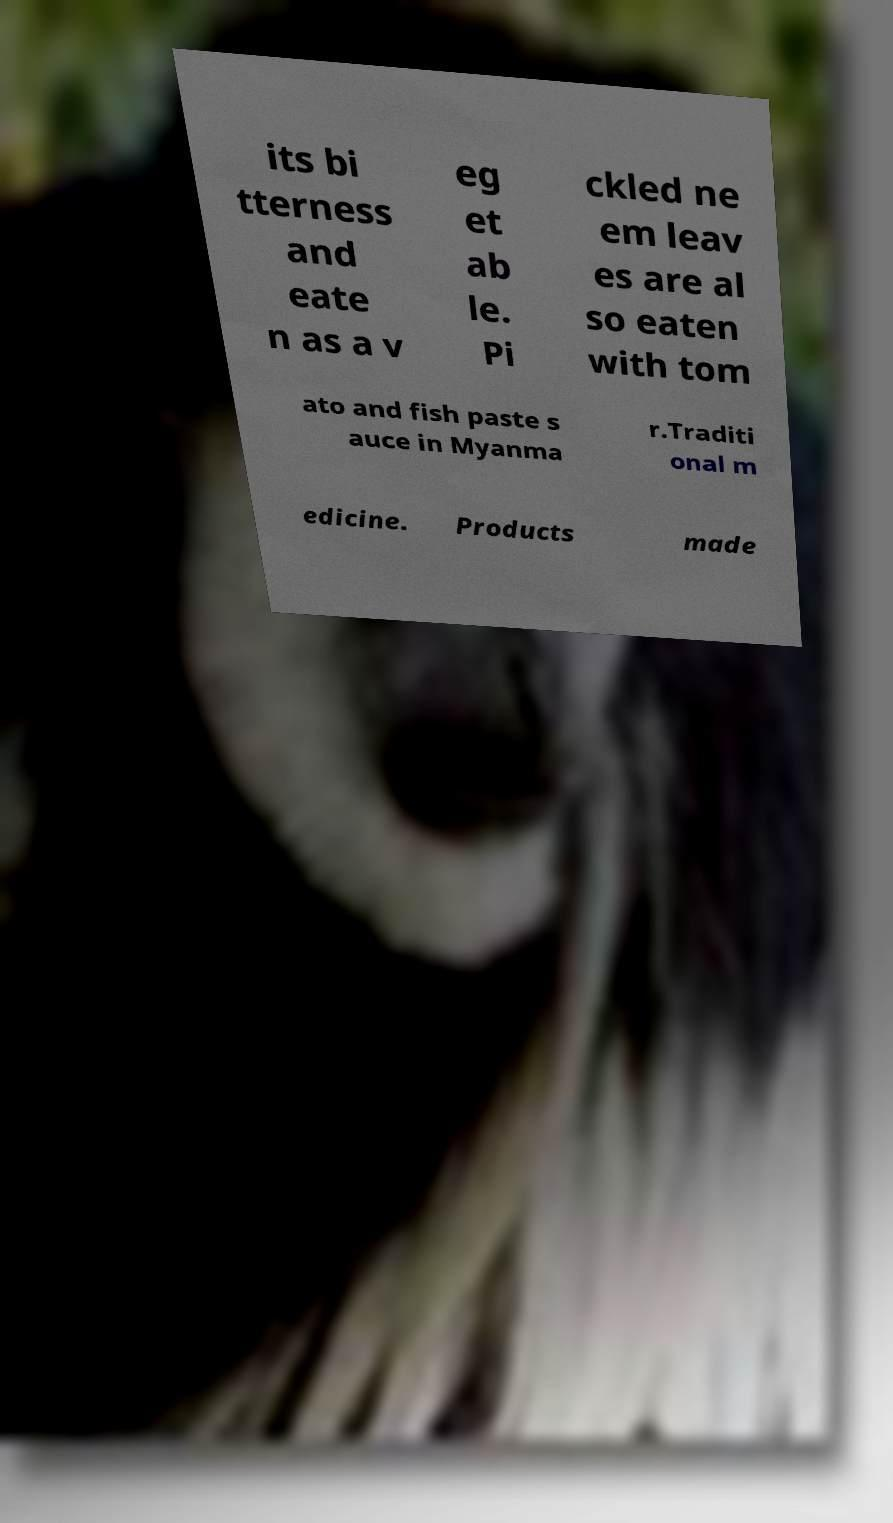Could you assist in decoding the text presented in this image and type it out clearly? its bi tterness and eate n as a v eg et ab le. Pi ckled ne em leav es are al so eaten with tom ato and fish paste s auce in Myanma r.Traditi onal m edicine. Products made 